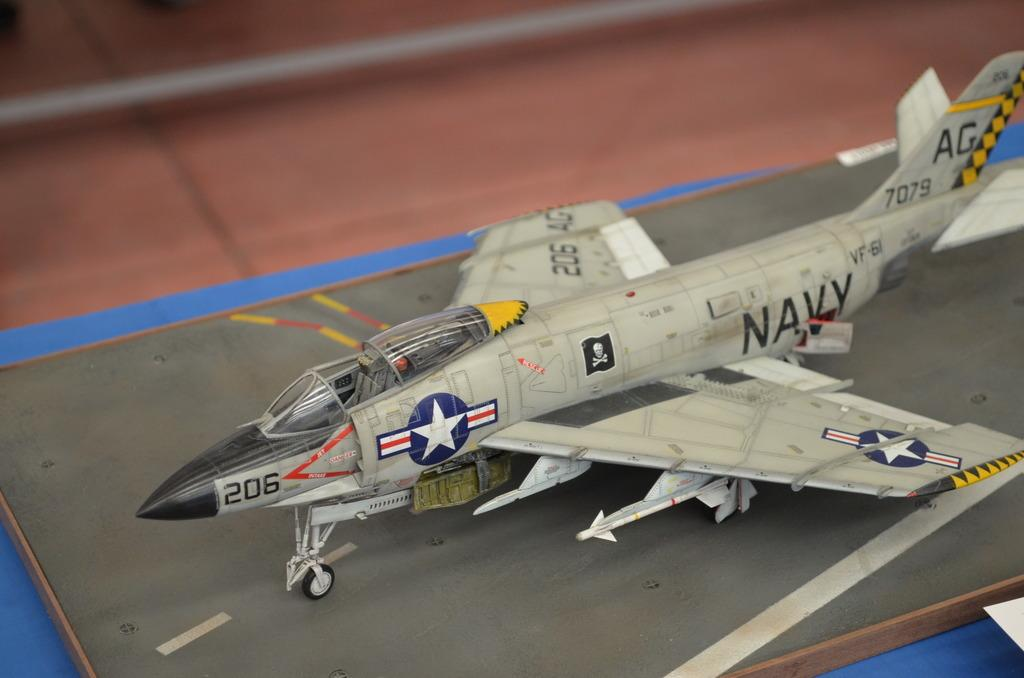<image>
Create a compact narrative representing the image presented. A model Navy place sits on a model runway. 